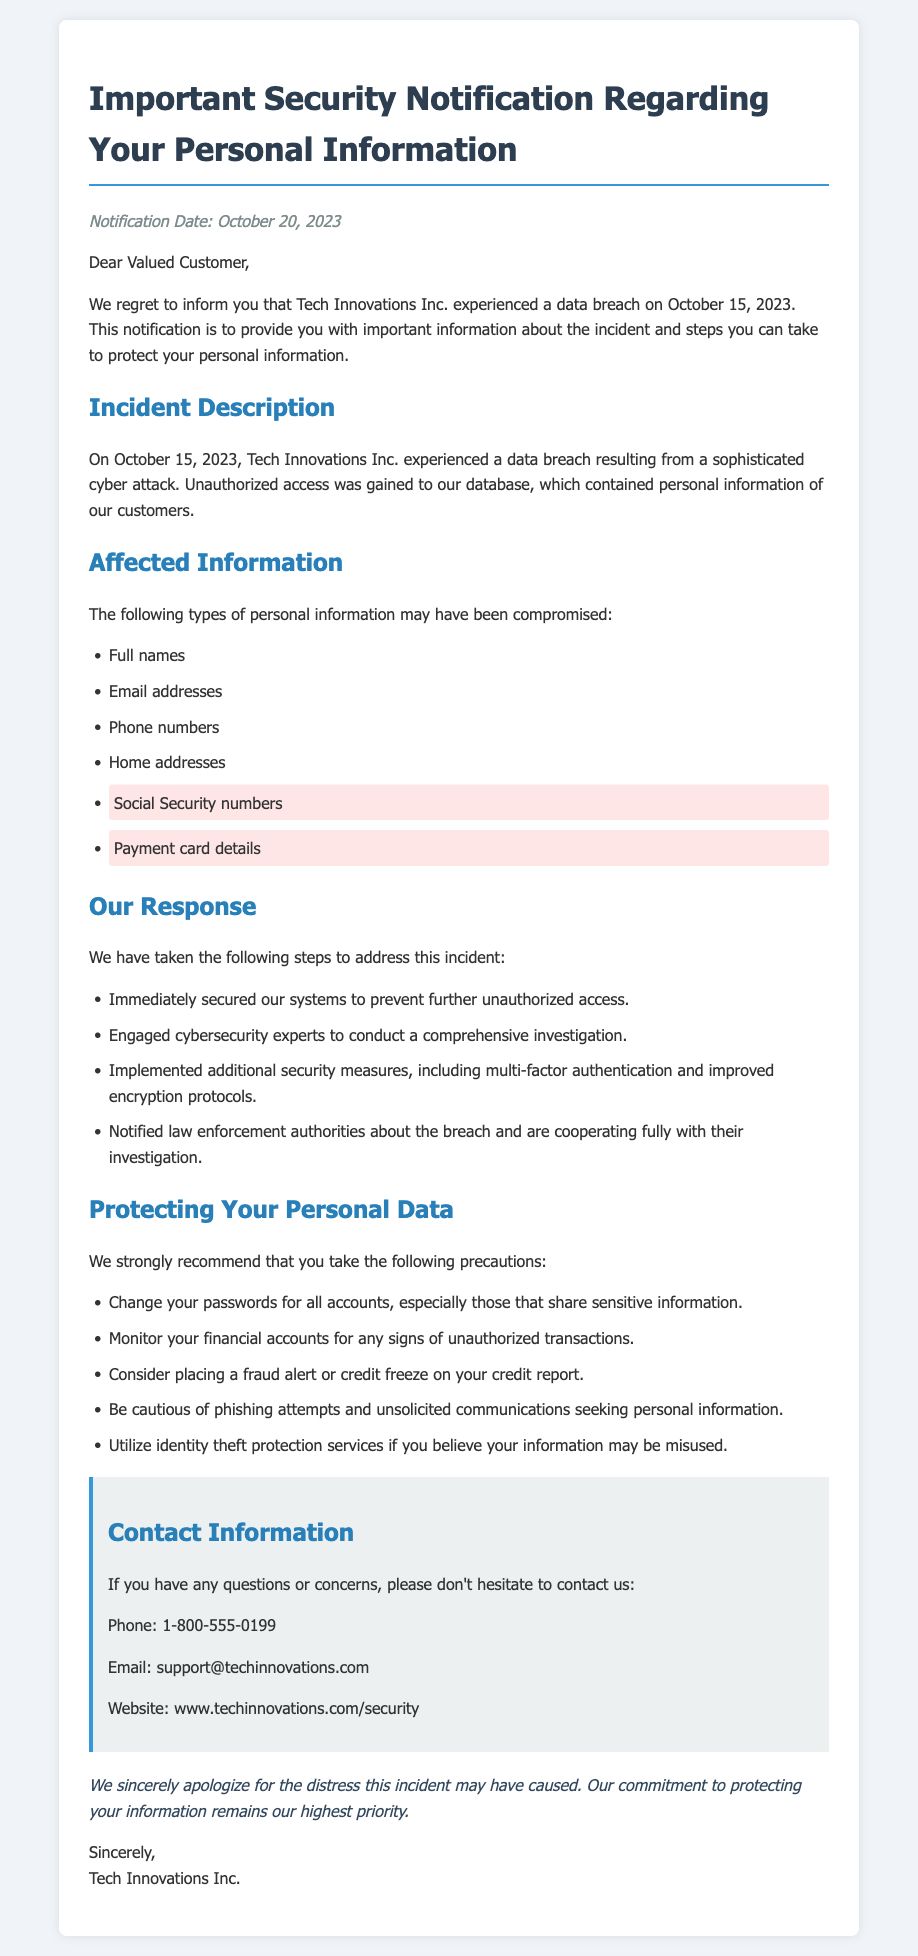What is the notification date? The notification date is provided in the document to inform the customers of when they were notified about the breach.
Answer: October 20, 2023 Who experienced the data breach? The document specifies the organization that encountered the breach, making it clear who is responsible for the notification.
Answer: Tech Innovations Inc What type of sensitive information was highlighted? The document emphasizes specific types of personal information compromised during the breach, which are marked for importance.
Answer: Social Security numbers What security measures were implemented? The document lists actions taken to secure the system after the breach and outlines the measures that were put in place.
Answer: Multi-factor authentication How should customers protect their accounts? The document recommends specific actions customers should take as precautions post-breach, highlighting the most crucial steps to take.
Answer: Change your passwords When did the data breach occur? The document provides a specific date for when the incident took place, allowing customers to understand when their information may have been compromised.
Answer: October 15, 2023 Which authorities were notified about the breach? The document mentions the engagement of law enforcement authorities, which is a standard procedure in such incidents, to promote transparency.
Answer: Law enforcement authorities What comprises the affected information? The document lists various pieces of personal information that may have been compromised, giving customers an overview of what may be at risk.
Answer: Full names, Email addresses, Phone numbers, Home addresses, Social Security numbers, Payment card details 